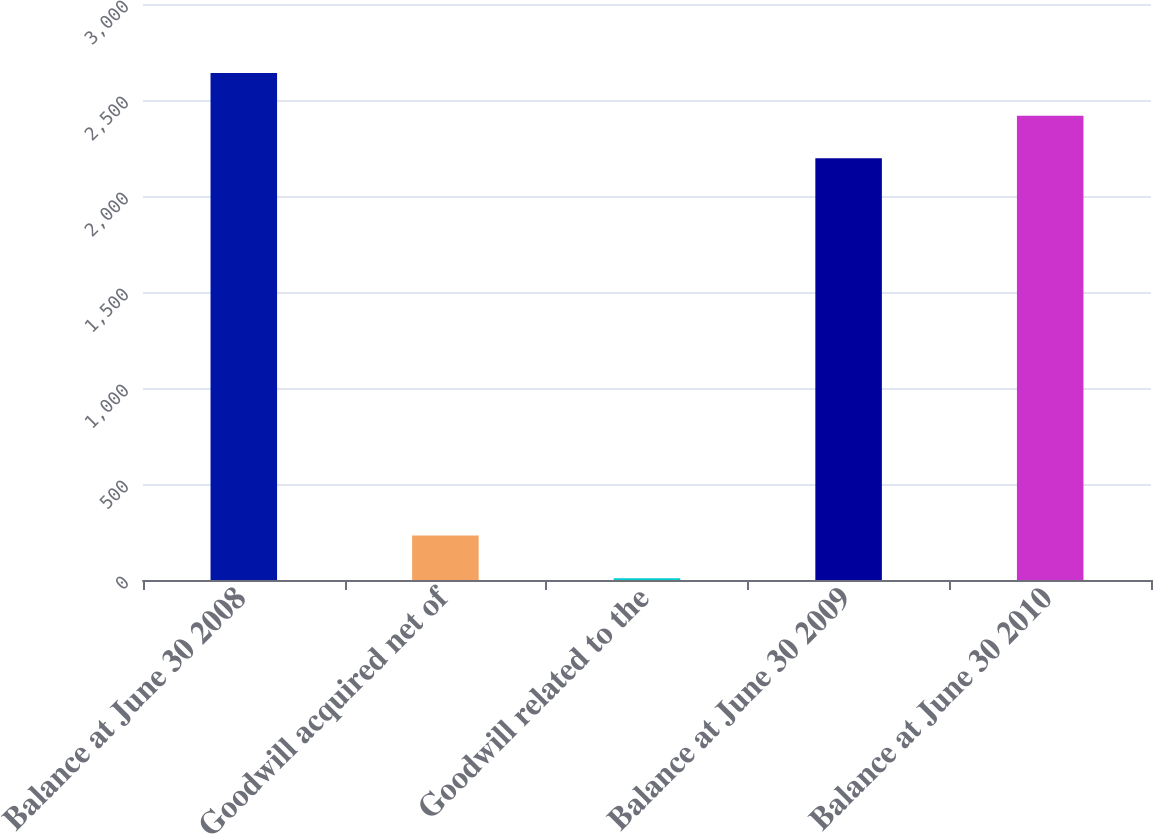<chart> <loc_0><loc_0><loc_500><loc_500><bar_chart><fcel>Balance at June 30 2008<fcel>Goodwill acquired net of<fcel>Goodwill related to the<fcel>Balance at June 30 2009<fcel>Balance at June 30 2010<nl><fcel>2640.46<fcel>231.48<fcel>9.5<fcel>2196.5<fcel>2418.48<nl></chart> 